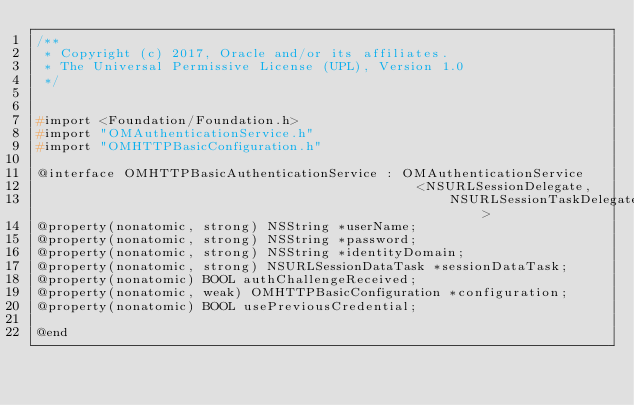Convert code to text. <code><loc_0><loc_0><loc_500><loc_500><_C_>/**
 * Copyright (c) 2017, Oracle and/or its affiliates.
 * The Universal Permissive License (UPL), Version 1.0
 */


#import <Foundation/Foundation.h>
#import "OMAuthenticationService.h"
#import "OMHTTPBasicConfiguration.h"

@interface OMHTTPBasicAuthenticationService : OMAuthenticationService
                                                <NSURLSessionDelegate,
                                                    NSURLSessionTaskDelegate>
@property(nonatomic, strong) NSString *userName;
@property(nonatomic, strong) NSString *password;
@property(nonatomic, strong) NSString *identityDomain;
@property(nonatomic, strong) NSURLSessionDataTask *sessionDataTask;
@property(nonatomic) BOOL authChallengeReceived;
@property(nonatomic, weak) OMHTTPBasicConfiguration *configuration;
@property(nonatomic) BOOL usePreviousCredential;

@end
</code> 